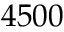<formula> <loc_0><loc_0><loc_500><loc_500>4 5 0 0</formula> 